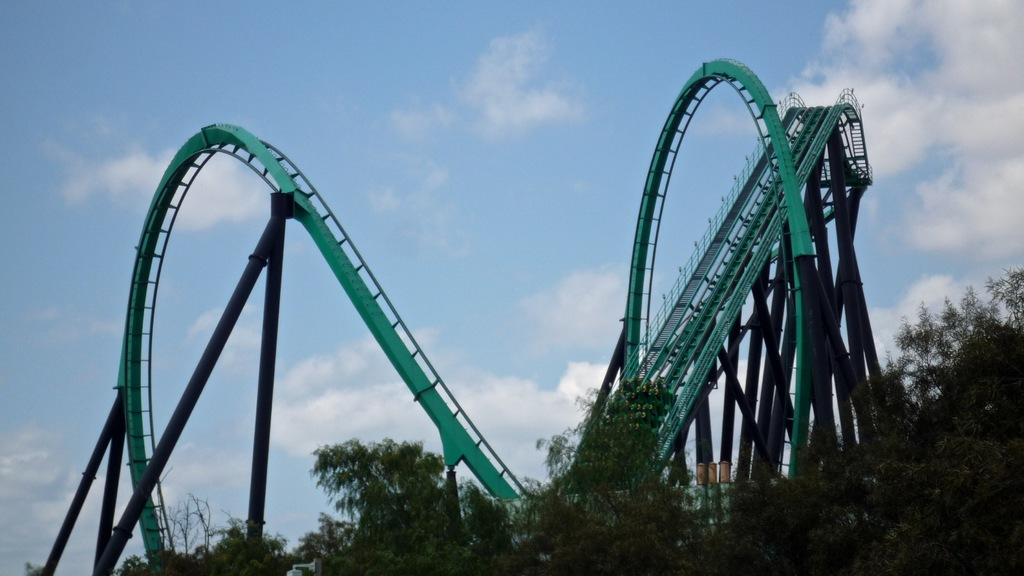What is the main subject of the picture? The main subject of the picture is a roller coaster. What else can be seen in the picture besides the roller coaster? There are trees in the picture. How many cakes are being served on the roller coaster in the picture? There are no cakes present in the image, as it features a roller coaster and trees. 